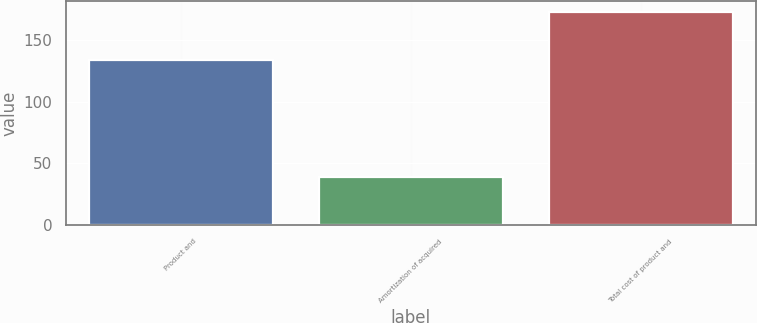<chart> <loc_0><loc_0><loc_500><loc_500><bar_chart><fcel>Product and<fcel>Amortization of acquired<fcel>Total cost of product and<nl><fcel>133.8<fcel>39.2<fcel>173<nl></chart> 